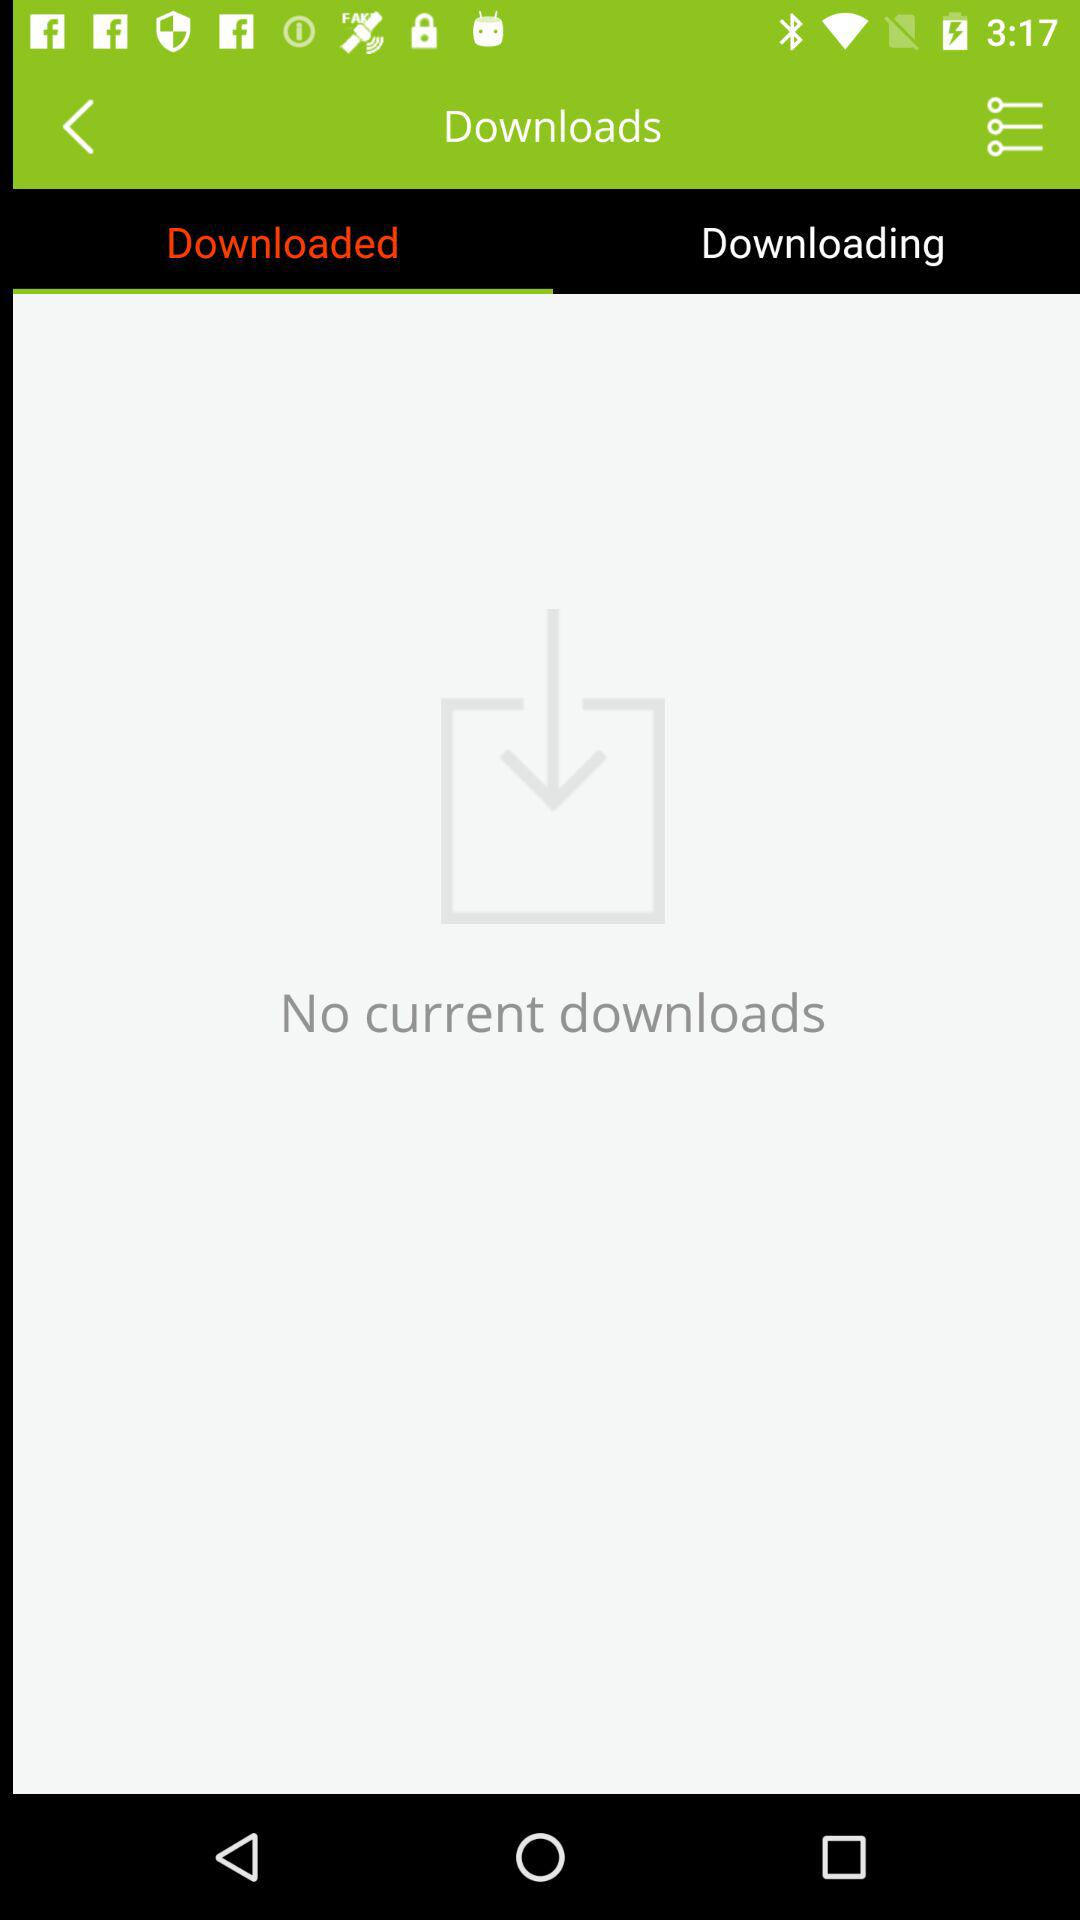Which items are currently downloading?
When the provided information is insufficient, respond with <no answer>. <no answer> 